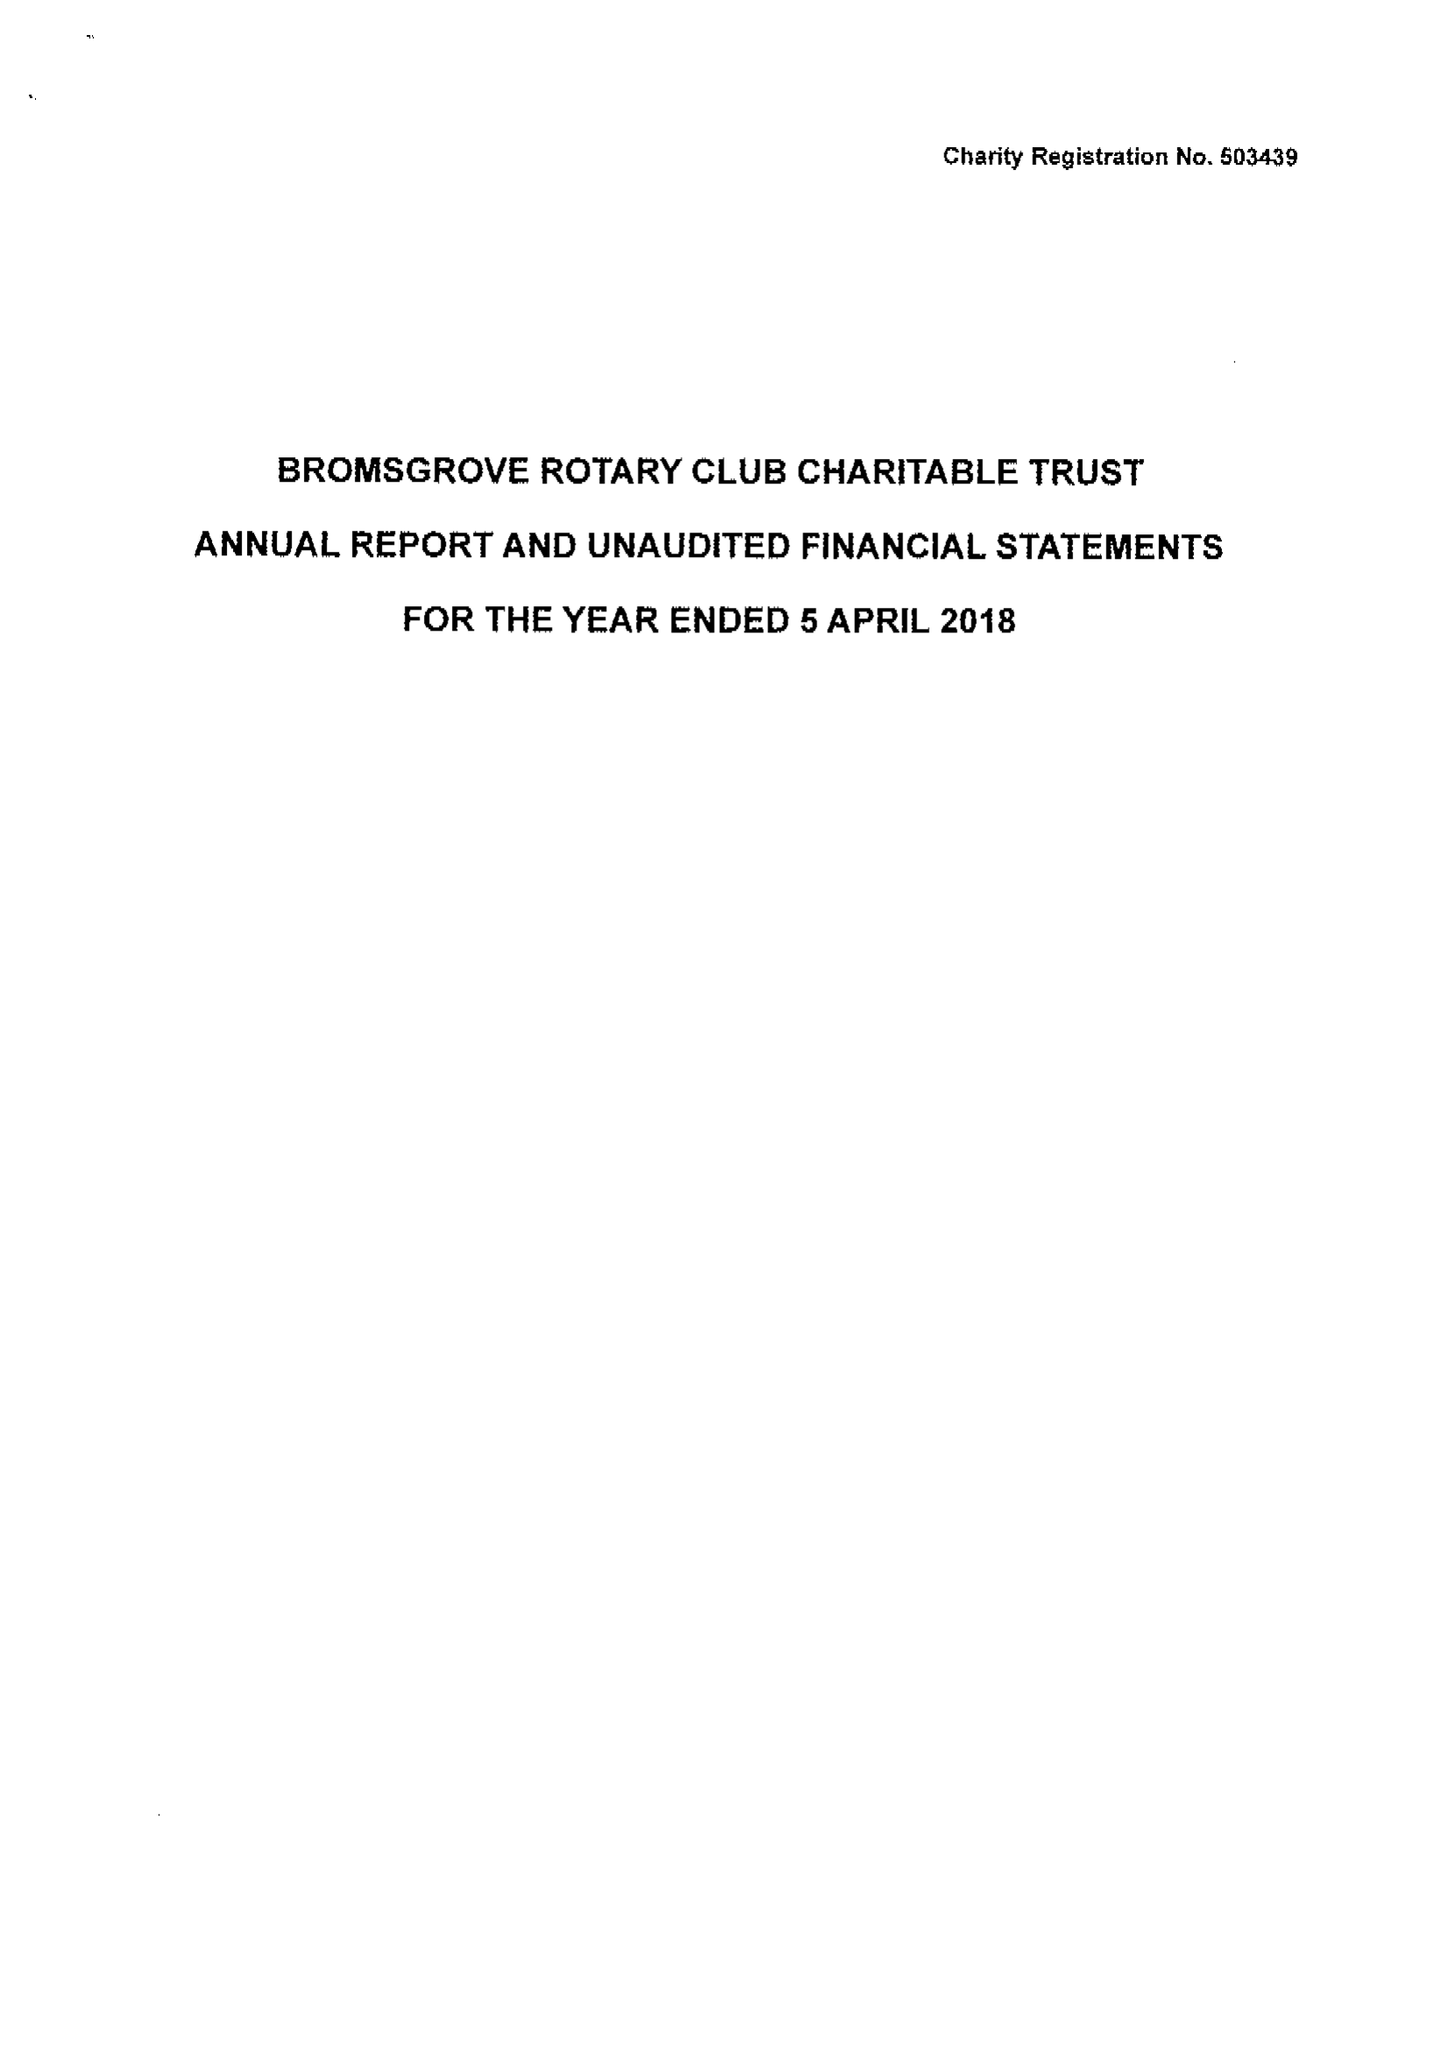What is the value for the charity_name?
Answer the question using a single word or phrase. Bromsgrove Rotary Club Charitable Trust 